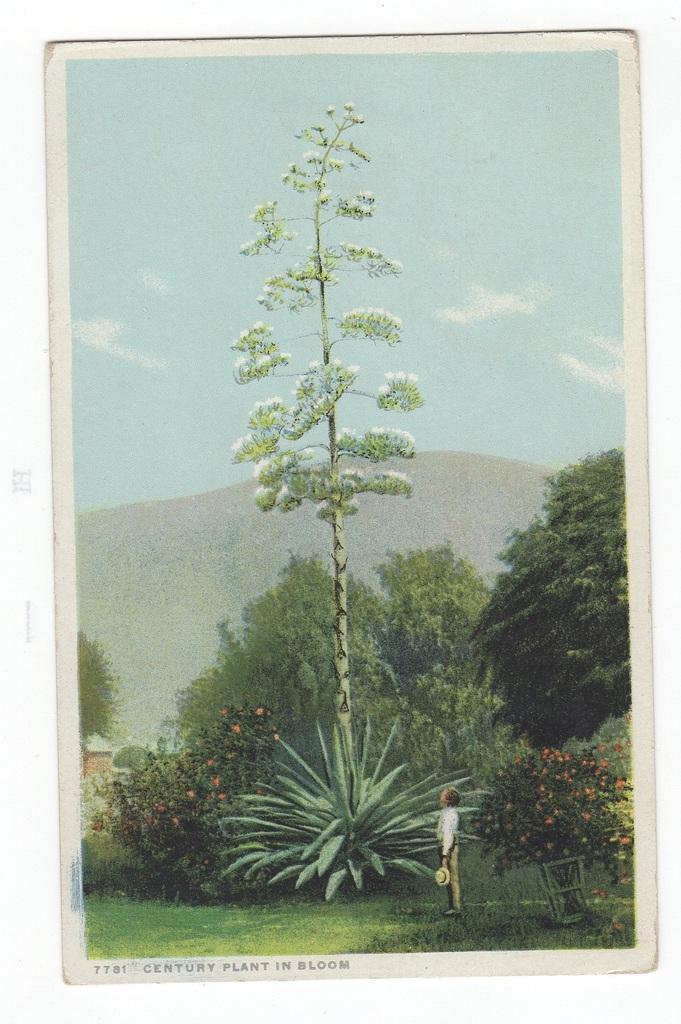Can you describe this image briefly? There is a poster, in which, there is a person standing on the grass on the ground, near a plant which is having flowers and near a tree. In the background, there are trees, there is a hill and there are clouds in the sky. 